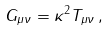Convert formula to latex. <formula><loc_0><loc_0><loc_500><loc_500>G _ { \mu \nu } = \kappa ^ { 2 } T _ { \mu \nu } \, ,</formula> 